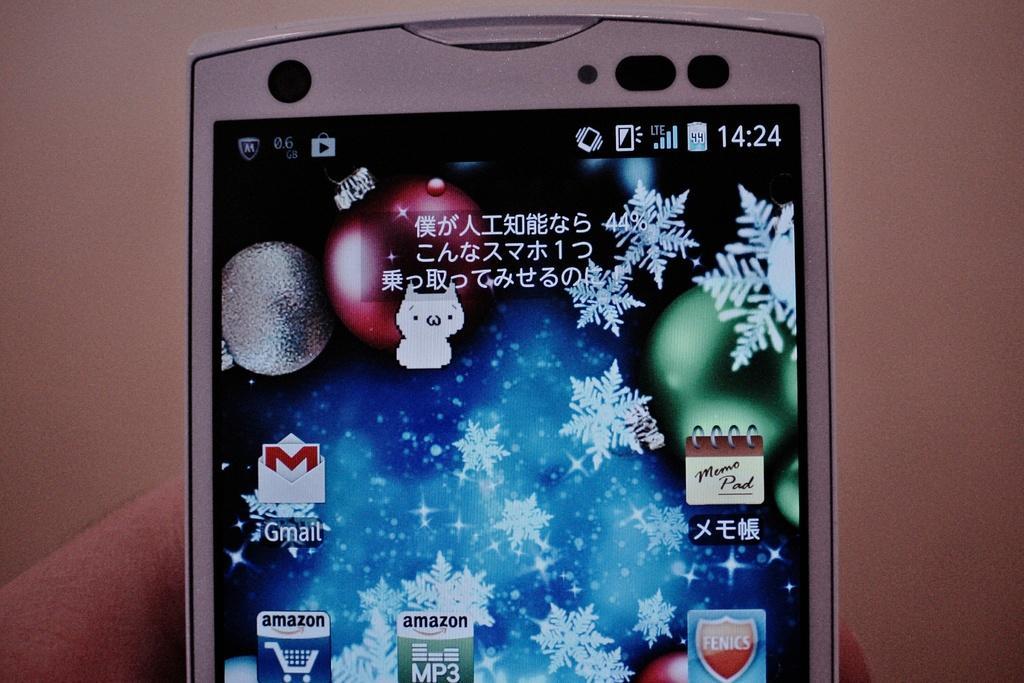Can you describe this image briefly? We can see mobile hold with fingers and screen. In the background it is brown color. 